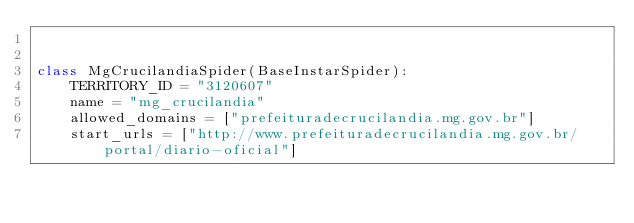<code> <loc_0><loc_0><loc_500><loc_500><_Python_>

class MgCrucilandiaSpider(BaseInstarSpider):
    TERRITORY_ID = "3120607"
    name = "mg_crucilandia"
    allowed_domains = ["prefeituradecrucilandia.mg.gov.br"]
    start_urls = ["http://www.prefeituradecrucilandia.mg.gov.br/portal/diario-oficial"]
</code> 